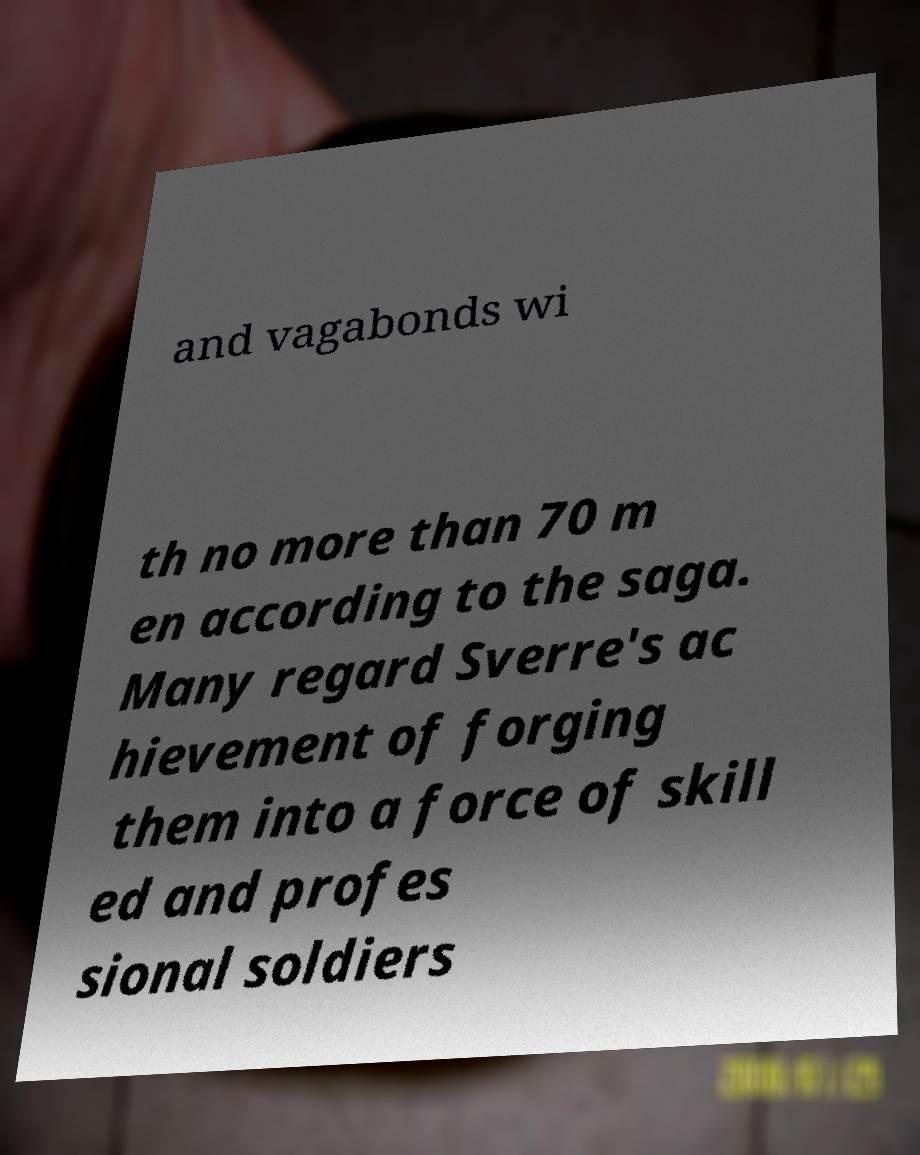Can you read and provide the text displayed in the image?This photo seems to have some interesting text. Can you extract and type it out for me? and vagabonds wi th no more than 70 m en according to the saga. Many regard Sverre's ac hievement of forging them into a force of skill ed and profes sional soldiers 